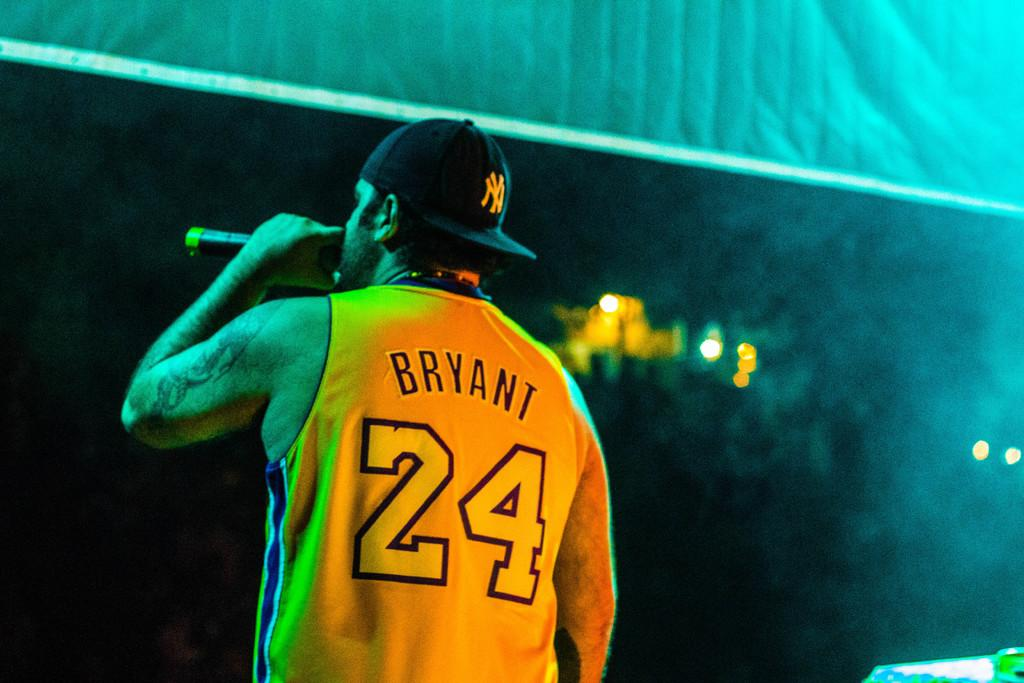<image>
Write a terse but informative summary of the picture. A man wearing a yellow Jersey that says Bryant 24 holds a microphone 